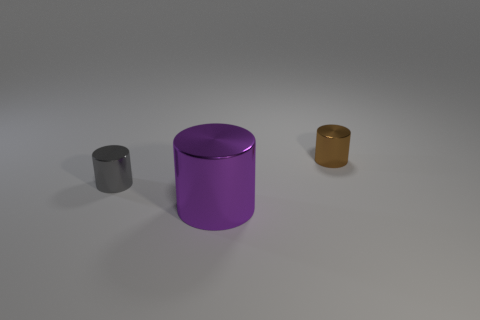Add 1 large cyan matte spheres. How many objects exist? 4 Subtract all small brown rubber balls. Subtract all big purple cylinders. How many objects are left? 2 Add 2 tiny gray metallic things. How many tiny gray metallic things are left? 3 Add 1 brown shiny things. How many brown shiny things exist? 2 Subtract 0 red cylinders. How many objects are left? 3 